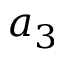Convert formula to latex. <formula><loc_0><loc_0><loc_500><loc_500>a _ { 3 }</formula> 